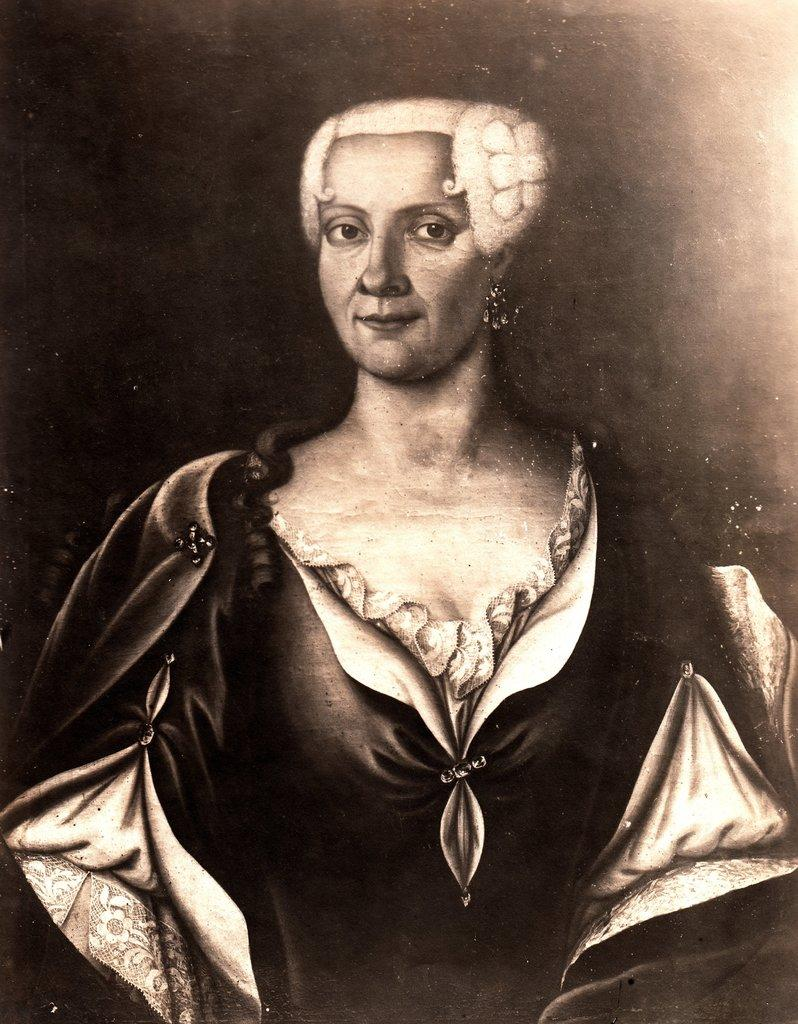Who is the main subject in the image? There is a woman in the image. What is the woman wearing? The woman is wearing a black dress. What color is the background of the image? The background of the image is black. How many apples are on the front of the woman's dress in the image? There are no apples visible on the woman's dress in the image. What word is written on the front of the woman's dress in the image? There is no word written on the front of the woman's dress in the image. 